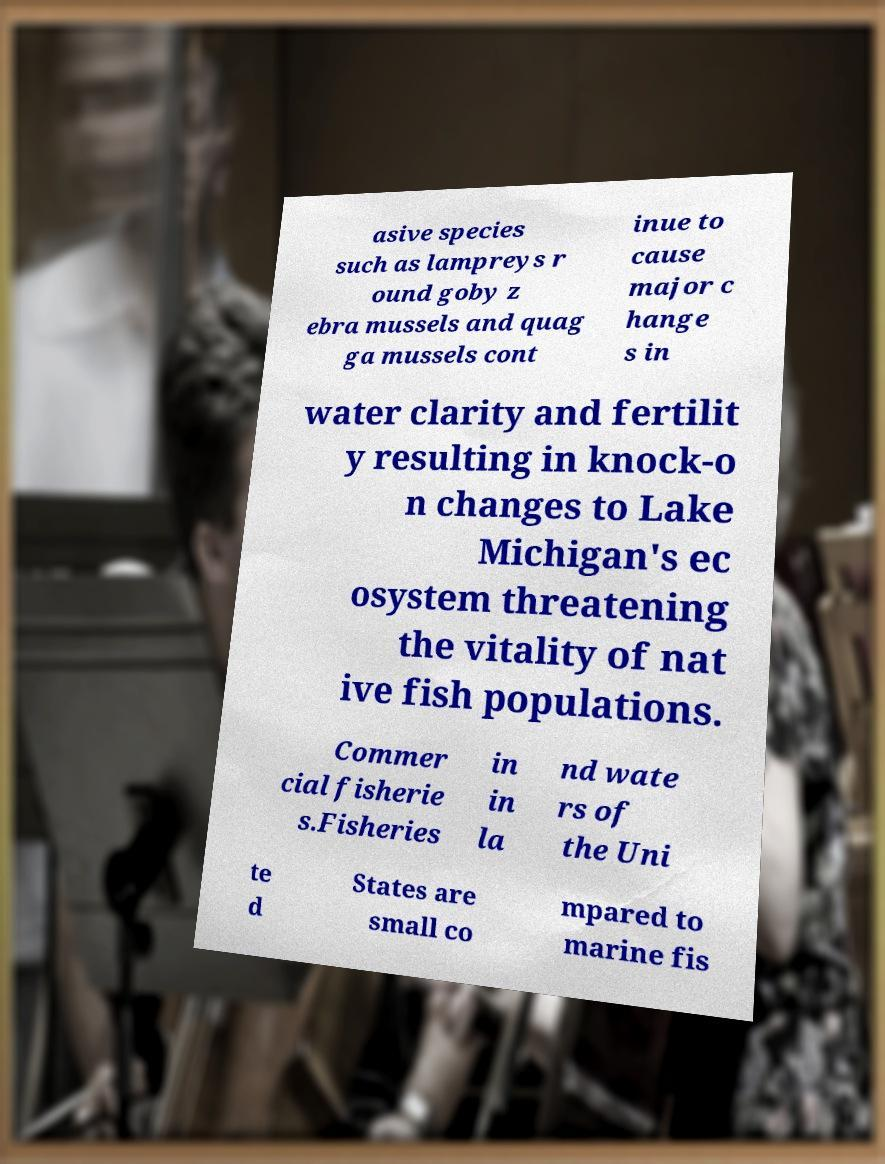Please identify and transcribe the text found in this image. asive species such as lampreys r ound goby z ebra mussels and quag ga mussels cont inue to cause major c hange s in water clarity and fertilit y resulting in knock-o n changes to Lake Michigan's ec osystem threatening the vitality of nat ive fish populations. Commer cial fisherie s.Fisheries in in la nd wate rs of the Uni te d States are small co mpared to marine fis 